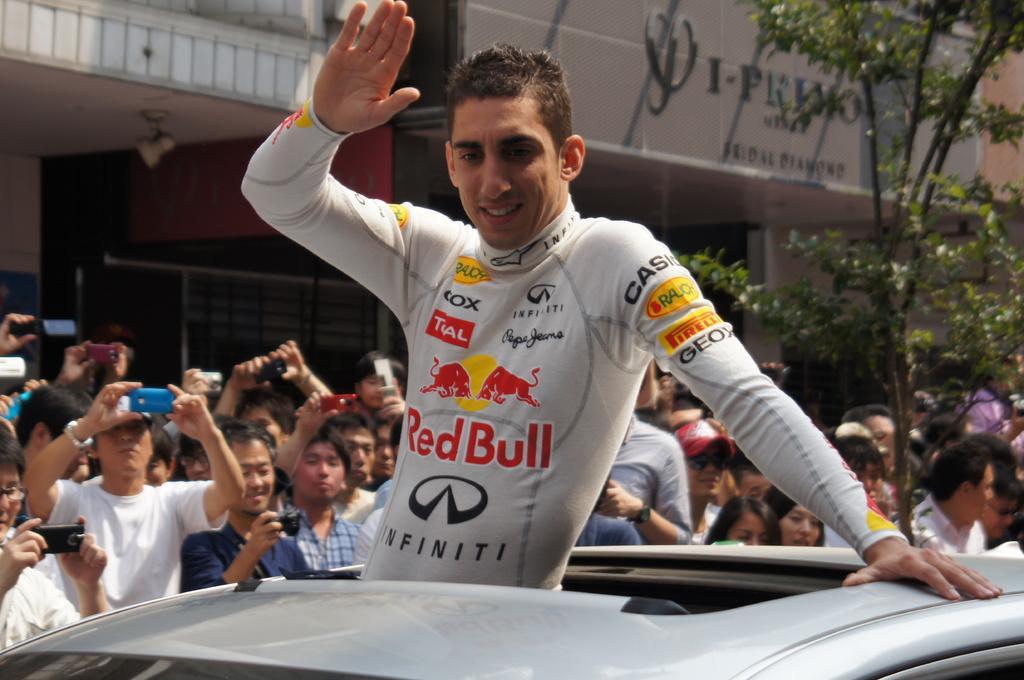Please provide a concise description of this image. In this picture we can see a car and a man in the front, there are some people standing in the middle, some of those people are holding mobile phones, on the right side there are trees, we can see buildings in the background. 